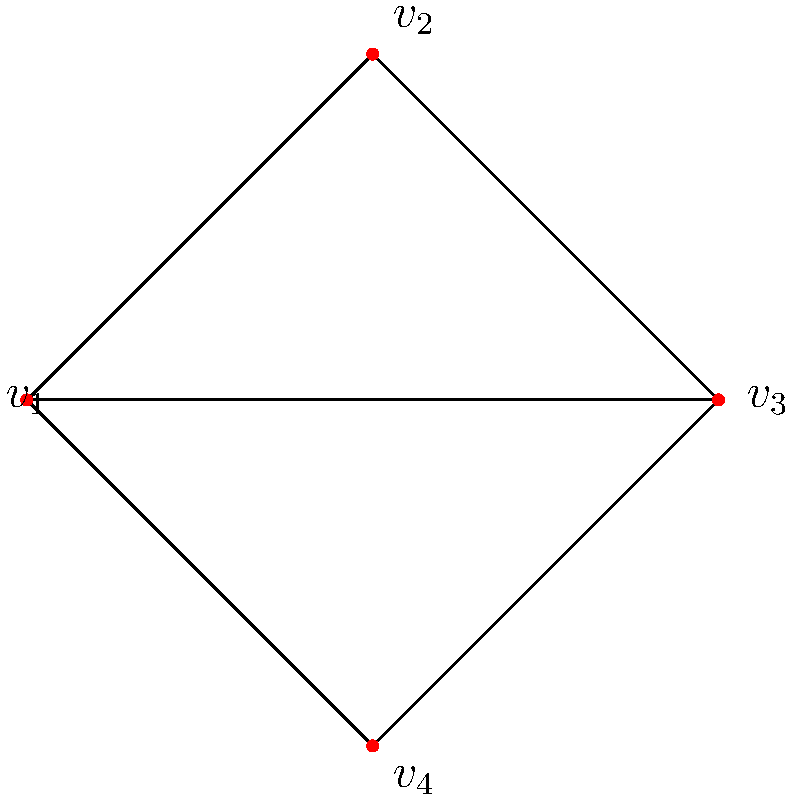Given the functional brain network represented by the graph above, where vertices represent brain regions and edges represent functional connections, determine the automorphism group of this network. What does the order of this group imply about the symmetry in the functional organization of these brain regions? To solve this problem, we'll follow these steps:

1) First, let's identify the symmetries of the graph:
   - The graph has a reflection symmetry across the vertical axis passing through $v_1$ and $v_3$.
   - It also has a 180-degree rotational symmetry around the center.

2) These symmetries correspond to the following permutations of vertices:
   - Identity: $(v_1)(v_2)(v_3)(v_4)$
   - Reflection: $(v_1)(v_3)(v_2 v_4)$
   - 180-degree rotation: $(v_1 v_3)(v_2 v_4)$

3) These permutations form a group under composition. Let's call this group $G$.

4) We can verify that $G$ is isomorphic to the Klein four-group $V_4$, which has order 4.

5) The order of the automorphism group tells us about the degree of symmetry in the network:
   - An order of 4 implies a significant degree of symmetry, but not complete symmetry.
   - It suggests that there are four ways to map the network onto itself while preserving its structure.

6) In terms of functional organization:
   - The symmetry implies that $v_2$ and $v_4$ have functionally equivalent roles in the network.
   - Similarly, $v_1$ and $v_3$ have functionally equivalent roles.
   - This suggests a paired organization of these brain regions in terms of their functional connectivity.

7) However, the limited order of the group (4 rather than 24, the maximum for a 4-vertex graph) indicates that there are still distinct functional roles among the regions, preserving some hierarchical or specialized organization.
Answer: Klein four-group $V_4$; implies paired functional equivalence with preserved specialization 